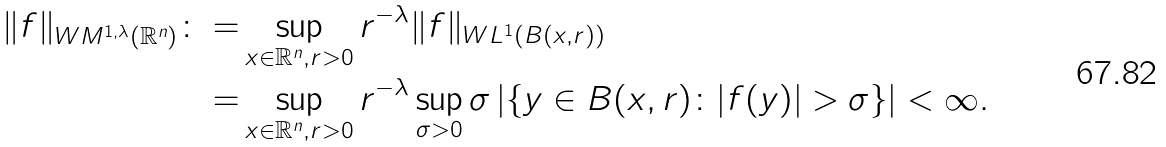<formula> <loc_0><loc_0><loc_500><loc_500>\| f \| _ { W M ^ { 1 , \lambda } ( \mathbb { R } ^ { n } ) } \colon = & \sup _ { x \in \mathbb { R } ^ { n } , r > 0 } r ^ { - \lambda } \| f \| _ { W L ^ { 1 } ( B ( x , r ) ) } \\ = & \sup _ { x \in \mathbb { R } ^ { n } , r > 0 } r ^ { - \lambda } \sup _ { \sigma > 0 } \sigma \left | \left \{ y \in B ( x , r ) \colon | f ( y ) | > \sigma \right \} \right | < \infty .</formula> 